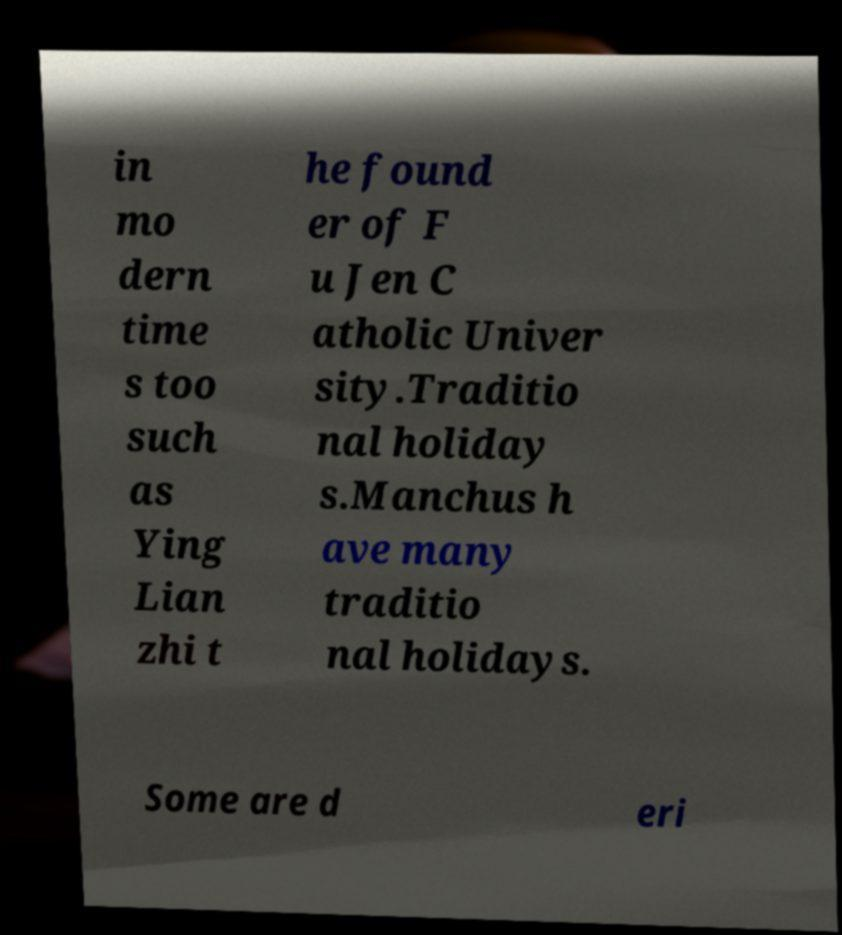There's text embedded in this image that I need extracted. Can you transcribe it verbatim? in mo dern time s too such as Ying Lian zhi t he found er of F u Jen C atholic Univer sity.Traditio nal holiday s.Manchus h ave many traditio nal holidays. Some are d eri 